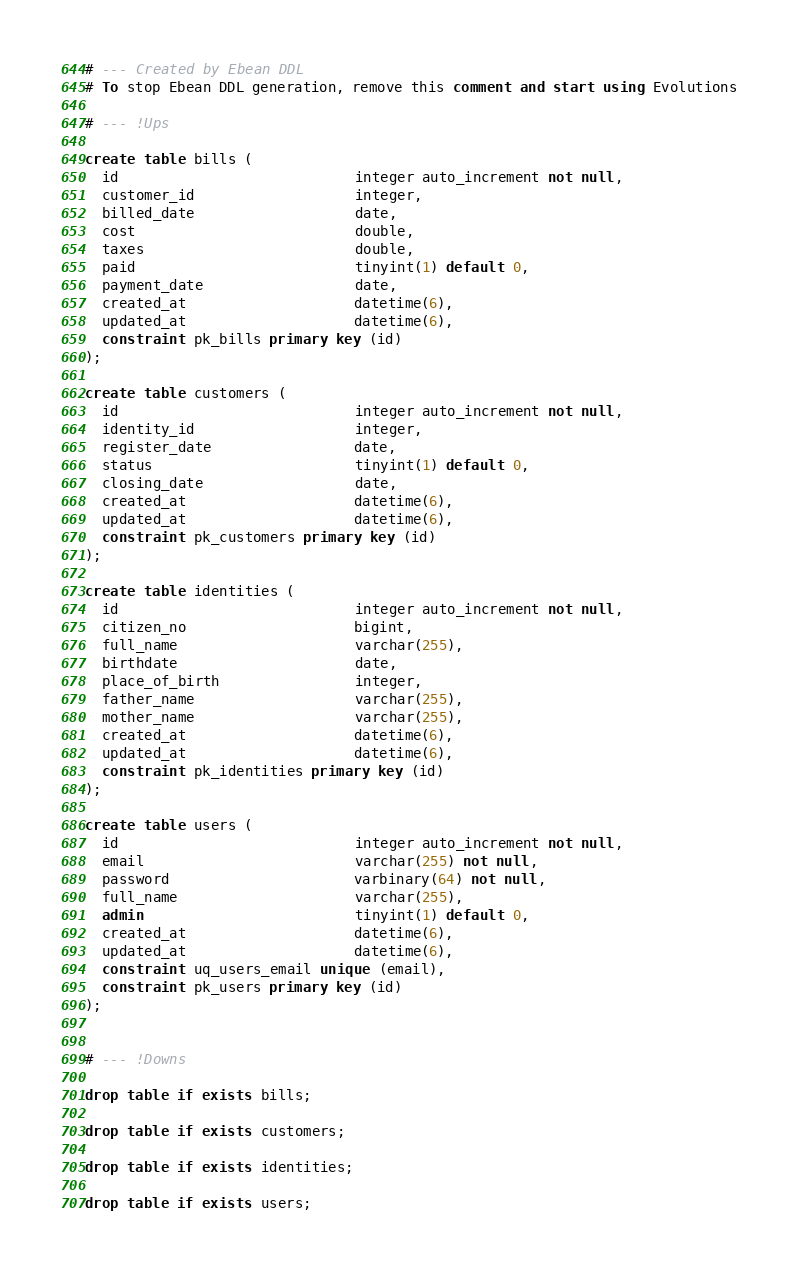Convert code to text. <code><loc_0><loc_0><loc_500><loc_500><_SQL_># --- Created by Ebean DDL
# To stop Ebean DDL generation, remove this comment and start using Evolutions

# --- !Ups

create table bills (
  id                            integer auto_increment not null,
  customer_id                   integer,
  billed_date                   date,
  cost                          double,
  taxes                         double,
  paid                          tinyint(1) default 0,
  payment_date                  date,
  created_at                    datetime(6),
  updated_at                    datetime(6),
  constraint pk_bills primary key (id)
);

create table customers (
  id                            integer auto_increment not null,
  identity_id                   integer,
  register_date                 date,
  status                        tinyint(1) default 0,
  closing_date                  date,
  created_at                    datetime(6),
  updated_at                    datetime(6),
  constraint pk_customers primary key (id)
);

create table identities (
  id                            integer auto_increment not null,
  citizen_no                    bigint,
  full_name                     varchar(255),
  birthdate                     date,
  place_of_birth                integer,
  father_name                   varchar(255),
  mother_name                   varchar(255),
  created_at                    datetime(6),
  updated_at                    datetime(6),
  constraint pk_identities primary key (id)
);

create table users (
  id                            integer auto_increment not null,
  email                         varchar(255) not null,
  password                      varbinary(64) not null,
  full_name                     varchar(255),
  admin                         tinyint(1) default 0,
  created_at                    datetime(6),
  updated_at                    datetime(6),
  constraint uq_users_email unique (email),
  constraint pk_users primary key (id)
);


# --- !Downs

drop table if exists bills;

drop table if exists customers;

drop table if exists identities;

drop table if exists users;

</code> 